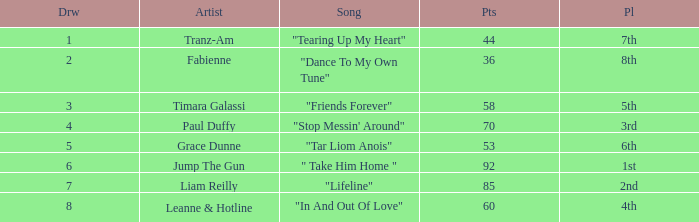What's the average amount of points for "in and out of love" with a draw over 8? None. 